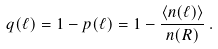<formula> <loc_0><loc_0><loc_500><loc_500>q ( \ell ) = 1 - p ( \ell ) = 1 - \frac { \langle n ( \ell ) \rangle } { n ( R ) } \, .</formula> 